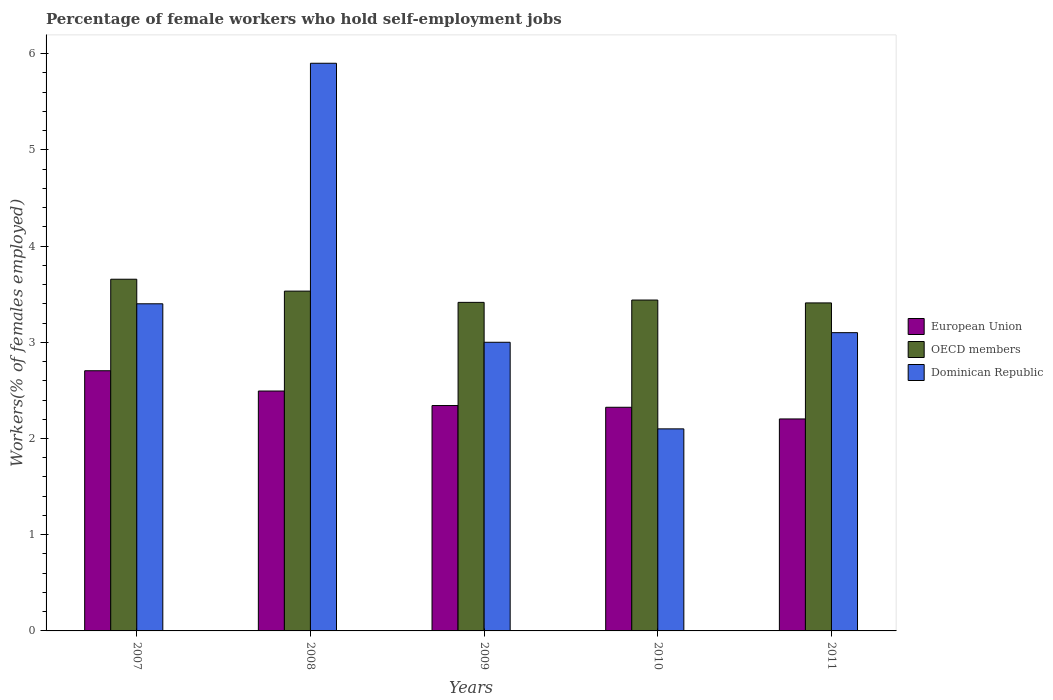How many groups of bars are there?
Provide a short and direct response. 5. Are the number of bars on each tick of the X-axis equal?
Offer a terse response. Yes. How many bars are there on the 4th tick from the left?
Provide a short and direct response. 3. What is the label of the 5th group of bars from the left?
Keep it short and to the point. 2011. What is the percentage of self-employed female workers in Dominican Republic in 2008?
Your answer should be compact. 5.9. Across all years, what is the maximum percentage of self-employed female workers in European Union?
Provide a succinct answer. 2.7. Across all years, what is the minimum percentage of self-employed female workers in Dominican Republic?
Your answer should be compact. 2.1. In which year was the percentage of self-employed female workers in OECD members maximum?
Provide a succinct answer. 2007. What is the difference between the percentage of self-employed female workers in European Union in 2007 and that in 2010?
Provide a succinct answer. 0.38. What is the difference between the percentage of self-employed female workers in European Union in 2007 and the percentage of self-employed female workers in OECD members in 2009?
Make the answer very short. -0.71. What is the average percentage of self-employed female workers in Dominican Republic per year?
Provide a short and direct response. 3.5. In the year 2011, what is the difference between the percentage of self-employed female workers in Dominican Republic and percentage of self-employed female workers in OECD members?
Provide a short and direct response. -0.31. What is the ratio of the percentage of self-employed female workers in OECD members in 2008 to that in 2010?
Give a very brief answer. 1.03. What is the difference between the highest and the second highest percentage of self-employed female workers in OECD members?
Make the answer very short. 0.12. What is the difference between the highest and the lowest percentage of self-employed female workers in European Union?
Your answer should be compact. 0.5. In how many years, is the percentage of self-employed female workers in Dominican Republic greater than the average percentage of self-employed female workers in Dominican Republic taken over all years?
Keep it short and to the point. 1. Is the sum of the percentage of self-employed female workers in Dominican Republic in 2010 and 2011 greater than the maximum percentage of self-employed female workers in OECD members across all years?
Make the answer very short. Yes. What does the 2nd bar from the left in 2009 represents?
Offer a very short reply. OECD members. What does the 3rd bar from the right in 2011 represents?
Your answer should be very brief. European Union. How many bars are there?
Provide a succinct answer. 15. How many years are there in the graph?
Offer a terse response. 5. Are the values on the major ticks of Y-axis written in scientific E-notation?
Your answer should be very brief. No. Where does the legend appear in the graph?
Your answer should be compact. Center right. What is the title of the graph?
Provide a short and direct response. Percentage of female workers who hold self-employment jobs. Does "Cayman Islands" appear as one of the legend labels in the graph?
Your answer should be very brief. No. What is the label or title of the Y-axis?
Your response must be concise. Workers(% of females employed). What is the Workers(% of females employed) in European Union in 2007?
Give a very brief answer. 2.7. What is the Workers(% of females employed) of OECD members in 2007?
Offer a very short reply. 3.66. What is the Workers(% of females employed) of Dominican Republic in 2007?
Provide a succinct answer. 3.4. What is the Workers(% of females employed) of European Union in 2008?
Give a very brief answer. 2.49. What is the Workers(% of females employed) of OECD members in 2008?
Offer a terse response. 3.53. What is the Workers(% of females employed) of Dominican Republic in 2008?
Give a very brief answer. 5.9. What is the Workers(% of females employed) in European Union in 2009?
Offer a very short reply. 2.34. What is the Workers(% of females employed) of OECD members in 2009?
Offer a very short reply. 3.41. What is the Workers(% of females employed) of European Union in 2010?
Your answer should be compact. 2.32. What is the Workers(% of females employed) of OECD members in 2010?
Provide a short and direct response. 3.44. What is the Workers(% of females employed) in Dominican Republic in 2010?
Keep it short and to the point. 2.1. What is the Workers(% of females employed) in European Union in 2011?
Offer a terse response. 2.2. What is the Workers(% of females employed) in OECD members in 2011?
Offer a very short reply. 3.41. What is the Workers(% of females employed) in Dominican Republic in 2011?
Provide a short and direct response. 3.1. Across all years, what is the maximum Workers(% of females employed) in European Union?
Offer a very short reply. 2.7. Across all years, what is the maximum Workers(% of females employed) of OECD members?
Your answer should be compact. 3.66. Across all years, what is the maximum Workers(% of females employed) in Dominican Republic?
Provide a short and direct response. 5.9. Across all years, what is the minimum Workers(% of females employed) in European Union?
Make the answer very short. 2.2. Across all years, what is the minimum Workers(% of females employed) in OECD members?
Your response must be concise. 3.41. Across all years, what is the minimum Workers(% of females employed) in Dominican Republic?
Provide a short and direct response. 2.1. What is the total Workers(% of females employed) of European Union in the graph?
Your answer should be very brief. 12.07. What is the total Workers(% of females employed) in OECD members in the graph?
Provide a short and direct response. 17.45. What is the total Workers(% of females employed) in Dominican Republic in the graph?
Ensure brevity in your answer.  17.5. What is the difference between the Workers(% of females employed) in European Union in 2007 and that in 2008?
Provide a succinct answer. 0.21. What is the difference between the Workers(% of females employed) of OECD members in 2007 and that in 2008?
Your answer should be very brief. 0.12. What is the difference between the Workers(% of females employed) of European Union in 2007 and that in 2009?
Make the answer very short. 0.36. What is the difference between the Workers(% of females employed) in OECD members in 2007 and that in 2009?
Your response must be concise. 0.24. What is the difference between the Workers(% of females employed) in Dominican Republic in 2007 and that in 2009?
Ensure brevity in your answer.  0.4. What is the difference between the Workers(% of females employed) in European Union in 2007 and that in 2010?
Your response must be concise. 0.38. What is the difference between the Workers(% of females employed) of OECD members in 2007 and that in 2010?
Provide a short and direct response. 0.22. What is the difference between the Workers(% of females employed) in European Union in 2007 and that in 2011?
Provide a short and direct response. 0.5. What is the difference between the Workers(% of females employed) in OECD members in 2007 and that in 2011?
Provide a short and direct response. 0.25. What is the difference between the Workers(% of females employed) of European Union in 2008 and that in 2009?
Your response must be concise. 0.15. What is the difference between the Workers(% of females employed) of OECD members in 2008 and that in 2009?
Ensure brevity in your answer.  0.12. What is the difference between the Workers(% of females employed) of Dominican Republic in 2008 and that in 2009?
Provide a succinct answer. 2.9. What is the difference between the Workers(% of females employed) of European Union in 2008 and that in 2010?
Provide a succinct answer. 0.17. What is the difference between the Workers(% of females employed) in OECD members in 2008 and that in 2010?
Your answer should be very brief. 0.09. What is the difference between the Workers(% of females employed) of European Union in 2008 and that in 2011?
Offer a very short reply. 0.29. What is the difference between the Workers(% of females employed) in OECD members in 2008 and that in 2011?
Give a very brief answer. 0.12. What is the difference between the Workers(% of females employed) of Dominican Republic in 2008 and that in 2011?
Provide a short and direct response. 2.8. What is the difference between the Workers(% of females employed) of European Union in 2009 and that in 2010?
Make the answer very short. 0.02. What is the difference between the Workers(% of females employed) in OECD members in 2009 and that in 2010?
Your answer should be compact. -0.02. What is the difference between the Workers(% of females employed) of European Union in 2009 and that in 2011?
Give a very brief answer. 0.14. What is the difference between the Workers(% of females employed) of OECD members in 2009 and that in 2011?
Your answer should be compact. 0.01. What is the difference between the Workers(% of females employed) in Dominican Republic in 2009 and that in 2011?
Provide a short and direct response. -0.1. What is the difference between the Workers(% of females employed) of European Union in 2010 and that in 2011?
Make the answer very short. 0.12. What is the difference between the Workers(% of females employed) of OECD members in 2010 and that in 2011?
Offer a terse response. 0.03. What is the difference between the Workers(% of females employed) in Dominican Republic in 2010 and that in 2011?
Keep it short and to the point. -1. What is the difference between the Workers(% of females employed) of European Union in 2007 and the Workers(% of females employed) of OECD members in 2008?
Offer a very short reply. -0.83. What is the difference between the Workers(% of females employed) in European Union in 2007 and the Workers(% of females employed) in Dominican Republic in 2008?
Give a very brief answer. -3.2. What is the difference between the Workers(% of females employed) in OECD members in 2007 and the Workers(% of females employed) in Dominican Republic in 2008?
Give a very brief answer. -2.24. What is the difference between the Workers(% of females employed) of European Union in 2007 and the Workers(% of females employed) of OECD members in 2009?
Provide a succinct answer. -0.71. What is the difference between the Workers(% of females employed) in European Union in 2007 and the Workers(% of females employed) in Dominican Republic in 2009?
Provide a short and direct response. -0.3. What is the difference between the Workers(% of females employed) in OECD members in 2007 and the Workers(% of females employed) in Dominican Republic in 2009?
Offer a very short reply. 0.66. What is the difference between the Workers(% of females employed) in European Union in 2007 and the Workers(% of females employed) in OECD members in 2010?
Your answer should be compact. -0.73. What is the difference between the Workers(% of females employed) in European Union in 2007 and the Workers(% of females employed) in Dominican Republic in 2010?
Your response must be concise. 0.6. What is the difference between the Workers(% of females employed) of OECD members in 2007 and the Workers(% of females employed) of Dominican Republic in 2010?
Ensure brevity in your answer.  1.56. What is the difference between the Workers(% of females employed) in European Union in 2007 and the Workers(% of females employed) in OECD members in 2011?
Offer a very short reply. -0.7. What is the difference between the Workers(% of females employed) of European Union in 2007 and the Workers(% of females employed) of Dominican Republic in 2011?
Your response must be concise. -0.4. What is the difference between the Workers(% of females employed) of OECD members in 2007 and the Workers(% of females employed) of Dominican Republic in 2011?
Keep it short and to the point. 0.56. What is the difference between the Workers(% of females employed) in European Union in 2008 and the Workers(% of females employed) in OECD members in 2009?
Offer a very short reply. -0.92. What is the difference between the Workers(% of females employed) in European Union in 2008 and the Workers(% of females employed) in Dominican Republic in 2009?
Make the answer very short. -0.51. What is the difference between the Workers(% of females employed) of OECD members in 2008 and the Workers(% of females employed) of Dominican Republic in 2009?
Ensure brevity in your answer.  0.53. What is the difference between the Workers(% of females employed) of European Union in 2008 and the Workers(% of females employed) of OECD members in 2010?
Offer a terse response. -0.95. What is the difference between the Workers(% of females employed) in European Union in 2008 and the Workers(% of females employed) in Dominican Republic in 2010?
Give a very brief answer. 0.39. What is the difference between the Workers(% of females employed) in OECD members in 2008 and the Workers(% of females employed) in Dominican Republic in 2010?
Offer a terse response. 1.43. What is the difference between the Workers(% of females employed) in European Union in 2008 and the Workers(% of females employed) in OECD members in 2011?
Your response must be concise. -0.92. What is the difference between the Workers(% of females employed) in European Union in 2008 and the Workers(% of females employed) in Dominican Republic in 2011?
Provide a succinct answer. -0.61. What is the difference between the Workers(% of females employed) in OECD members in 2008 and the Workers(% of females employed) in Dominican Republic in 2011?
Keep it short and to the point. 0.43. What is the difference between the Workers(% of females employed) of European Union in 2009 and the Workers(% of females employed) of OECD members in 2010?
Your response must be concise. -1.1. What is the difference between the Workers(% of females employed) in European Union in 2009 and the Workers(% of females employed) in Dominican Republic in 2010?
Give a very brief answer. 0.24. What is the difference between the Workers(% of females employed) of OECD members in 2009 and the Workers(% of females employed) of Dominican Republic in 2010?
Provide a short and direct response. 1.31. What is the difference between the Workers(% of females employed) in European Union in 2009 and the Workers(% of females employed) in OECD members in 2011?
Provide a short and direct response. -1.07. What is the difference between the Workers(% of females employed) in European Union in 2009 and the Workers(% of females employed) in Dominican Republic in 2011?
Make the answer very short. -0.76. What is the difference between the Workers(% of females employed) in OECD members in 2009 and the Workers(% of females employed) in Dominican Republic in 2011?
Your answer should be very brief. 0.31. What is the difference between the Workers(% of females employed) in European Union in 2010 and the Workers(% of females employed) in OECD members in 2011?
Give a very brief answer. -1.08. What is the difference between the Workers(% of females employed) of European Union in 2010 and the Workers(% of females employed) of Dominican Republic in 2011?
Offer a terse response. -0.78. What is the difference between the Workers(% of females employed) in OECD members in 2010 and the Workers(% of females employed) in Dominican Republic in 2011?
Your response must be concise. 0.34. What is the average Workers(% of females employed) of European Union per year?
Give a very brief answer. 2.41. What is the average Workers(% of females employed) of OECD members per year?
Provide a short and direct response. 3.49. What is the average Workers(% of females employed) of Dominican Republic per year?
Provide a succinct answer. 3.5. In the year 2007, what is the difference between the Workers(% of females employed) of European Union and Workers(% of females employed) of OECD members?
Your answer should be compact. -0.95. In the year 2007, what is the difference between the Workers(% of females employed) of European Union and Workers(% of females employed) of Dominican Republic?
Keep it short and to the point. -0.7. In the year 2007, what is the difference between the Workers(% of females employed) in OECD members and Workers(% of females employed) in Dominican Republic?
Offer a terse response. 0.26. In the year 2008, what is the difference between the Workers(% of females employed) in European Union and Workers(% of females employed) in OECD members?
Offer a very short reply. -1.04. In the year 2008, what is the difference between the Workers(% of females employed) in European Union and Workers(% of females employed) in Dominican Republic?
Provide a succinct answer. -3.41. In the year 2008, what is the difference between the Workers(% of females employed) in OECD members and Workers(% of females employed) in Dominican Republic?
Offer a terse response. -2.37. In the year 2009, what is the difference between the Workers(% of females employed) in European Union and Workers(% of females employed) in OECD members?
Offer a terse response. -1.07. In the year 2009, what is the difference between the Workers(% of females employed) of European Union and Workers(% of females employed) of Dominican Republic?
Your answer should be compact. -0.66. In the year 2009, what is the difference between the Workers(% of females employed) in OECD members and Workers(% of females employed) in Dominican Republic?
Provide a succinct answer. 0.41. In the year 2010, what is the difference between the Workers(% of females employed) of European Union and Workers(% of females employed) of OECD members?
Provide a succinct answer. -1.11. In the year 2010, what is the difference between the Workers(% of females employed) of European Union and Workers(% of females employed) of Dominican Republic?
Ensure brevity in your answer.  0.22. In the year 2010, what is the difference between the Workers(% of females employed) in OECD members and Workers(% of females employed) in Dominican Republic?
Make the answer very short. 1.34. In the year 2011, what is the difference between the Workers(% of females employed) in European Union and Workers(% of females employed) in OECD members?
Your answer should be very brief. -1.21. In the year 2011, what is the difference between the Workers(% of females employed) of European Union and Workers(% of females employed) of Dominican Republic?
Offer a terse response. -0.9. In the year 2011, what is the difference between the Workers(% of females employed) in OECD members and Workers(% of females employed) in Dominican Republic?
Make the answer very short. 0.31. What is the ratio of the Workers(% of females employed) in European Union in 2007 to that in 2008?
Your response must be concise. 1.08. What is the ratio of the Workers(% of females employed) of OECD members in 2007 to that in 2008?
Provide a short and direct response. 1.03. What is the ratio of the Workers(% of females employed) of Dominican Republic in 2007 to that in 2008?
Provide a succinct answer. 0.58. What is the ratio of the Workers(% of females employed) in European Union in 2007 to that in 2009?
Your answer should be compact. 1.15. What is the ratio of the Workers(% of females employed) of OECD members in 2007 to that in 2009?
Offer a terse response. 1.07. What is the ratio of the Workers(% of females employed) in Dominican Republic in 2007 to that in 2009?
Your answer should be very brief. 1.13. What is the ratio of the Workers(% of females employed) of European Union in 2007 to that in 2010?
Your response must be concise. 1.16. What is the ratio of the Workers(% of females employed) in OECD members in 2007 to that in 2010?
Make the answer very short. 1.06. What is the ratio of the Workers(% of females employed) in Dominican Republic in 2007 to that in 2010?
Provide a short and direct response. 1.62. What is the ratio of the Workers(% of females employed) in European Union in 2007 to that in 2011?
Make the answer very short. 1.23. What is the ratio of the Workers(% of females employed) of OECD members in 2007 to that in 2011?
Keep it short and to the point. 1.07. What is the ratio of the Workers(% of females employed) of Dominican Republic in 2007 to that in 2011?
Keep it short and to the point. 1.1. What is the ratio of the Workers(% of females employed) in European Union in 2008 to that in 2009?
Offer a very short reply. 1.06. What is the ratio of the Workers(% of females employed) of OECD members in 2008 to that in 2009?
Your answer should be compact. 1.03. What is the ratio of the Workers(% of females employed) in Dominican Republic in 2008 to that in 2009?
Offer a very short reply. 1.97. What is the ratio of the Workers(% of females employed) in European Union in 2008 to that in 2010?
Provide a succinct answer. 1.07. What is the ratio of the Workers(% of females employed) in Dominican Republic in 2008 to that in 2010?
Ensure brevity in your answer.  2.81. What is the ratio of the Workers(% of females employed) in European Union in 2008 to that in 2011?
Ensure brevity in your answer.  1.13. What is the ratio of the Workers(% of females employed) in OECD members in 2008 to that in 2011?
Provide a succinct answer. 1.04. What is the ratio of the Workers(% of females employed) in Dominican Republic in 2008 to that in 2011?
Keep it short and to the point. 1.9. What is the ratio of the Workers(% of females employed) in OECD members in 2009 to that in 2010?
Give a very brief answer. 0.99. What is the ratio of the Workers(% of females employed) of Dominican Republic in 2009 to that in 2010?
Ensure brevity in your answer.  1.43. What is the ratio of the Workers(% of females employed) of European Union in 2009 to that in 2011?
Offer a very short reply. 1.06. What is the ratio of the Workers(% of females employed) of OECD members in 2009 to that in 2011?
Keep it short and to the point. 1. What is the ratio of the Workers(% of females employed) of European Union in 2010 to that in 2011?
Provide a succinct answer. 1.05. What is the ratio of the Workers(% of females employed) in OECD members in 2010 to that in 2011?
Ensure brevity in your answer.  1.01. What is the ratio of the Workers(% of females employed) in Dominican Republic in 2010 to that in 2011?
Offer a very short reply. 0.68. What is the difference between the highest and the second highest Workers(% of females employed) in European Union?
Offer a very short reply. 0.21. What is the difference between the highest and the second highest Workers(% of females employed) of OECD members?
Your response must be concise. 0.12. What is the difference between the highest and the second highest Workers(% of females employed) in Dominican Republic?
Your answer should be very brief. 2.5. What is the difference between the highest and the lowest Workers(% of females employed) of European Union?
Provide a succinct answer. 0.5. What is the difference between the highest and the lowest Workers(% of females employed) of OECD members?
Your answer should be very brief. 0.25. What is the difference between the highest and the lowest Workers(% of females employed) of Dominican Republic?
Offer a very short reply. 3.8. 